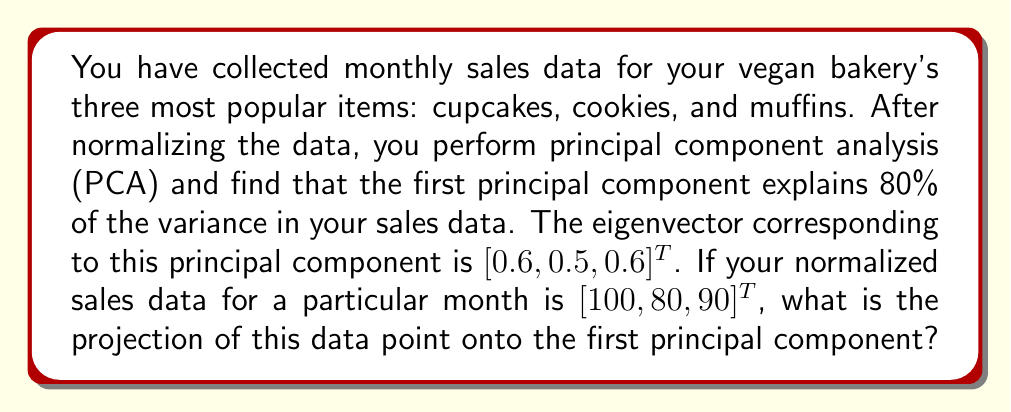Teach me how to tackle this problem. To solve this problem, we'll follow these steps:

1) The first principal component is given by the eigenvector $\vec{v} = [0.6, 0.5, 0.6]^T$.

2) Our normalized sales data point is $\vec{x} = [100, 80, 90]^T$.

3) To project $\vec{x}$ onto $\vec{v}$, we use the formula:

   $$\text{projection} = \frac{\vec{x} \cdot \vec{v}}{\|\vec{v}\|^2} \vec{v}$$

4) First, let's calculate the dot product $\vec{x} \cdot \vec{v}$:
   
   $$\vec{x} \cdot \vec{v} = 100(0.6) + 80(0.5) + 90(0.6) = 60 + 40 + 54 = 154$$

5) Next, we need to calculate $\|\vec{v}\|^2$:
   
   $$\|\vec{v}\|^2 = 0.6^2 + 0.5^2 + 0.6^2 = 0.36 + 0.25 + 0.36 = 0.97$$

6) Now we can calculate the scalar projection:

   $$\frac{\vec{x} \cdot \vec{v}}{\|\vec{v}\|^2} = \frac{154}{0.97} \approx 158.76$$

7) Finally, we multiply this scalar by $\vec{v}$ to get the vector projection:

   $$158.76 [0.6, 0.5, 0.6]^T \approx [95.26, 79.38, 95.26]^T$$

This is the projection of our sales data point onto the first principal component.
Answer: $[95.26, 79.38, 95.26]^T$ 